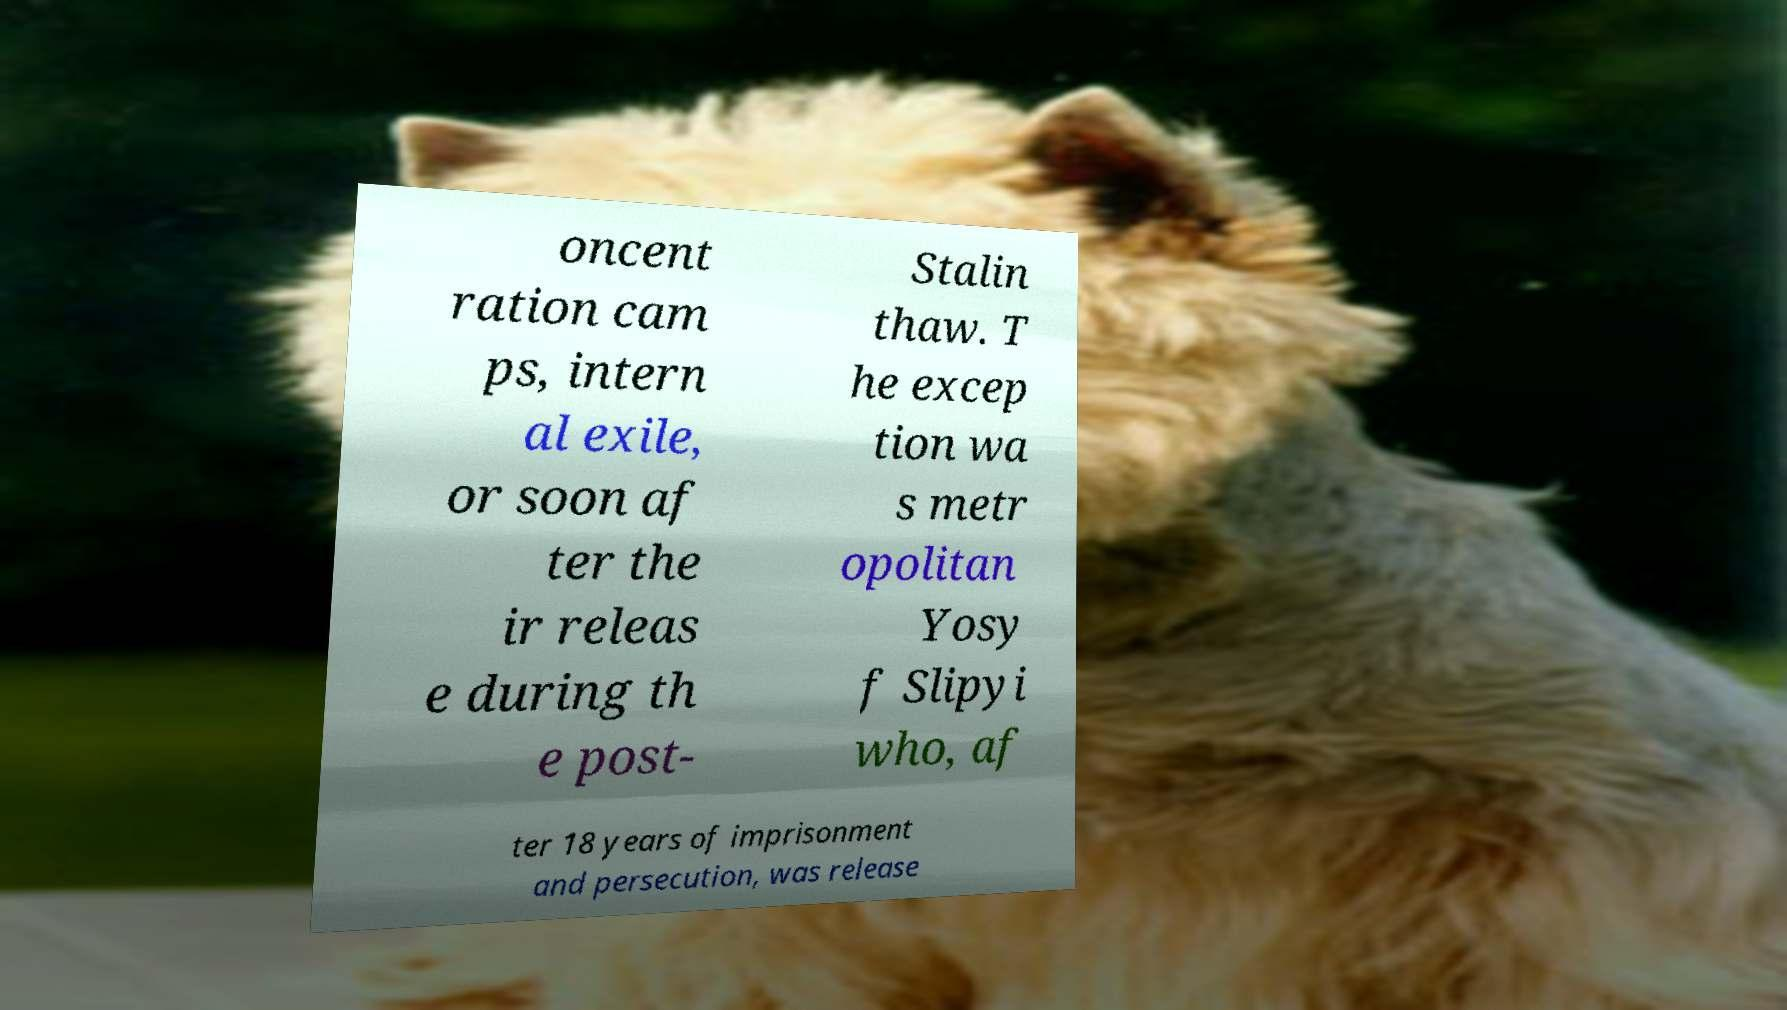Could you assist in decoding the text presented in this image and type it out clearly? oncent ration cam ps, intern al exile, or soon af ter the ir releas e during th e post- Stalin thaw. T he excep tion wa s metr opolitan Yosy f Slipyi who, af ter 18 years of imprisonment and persecution, was release 